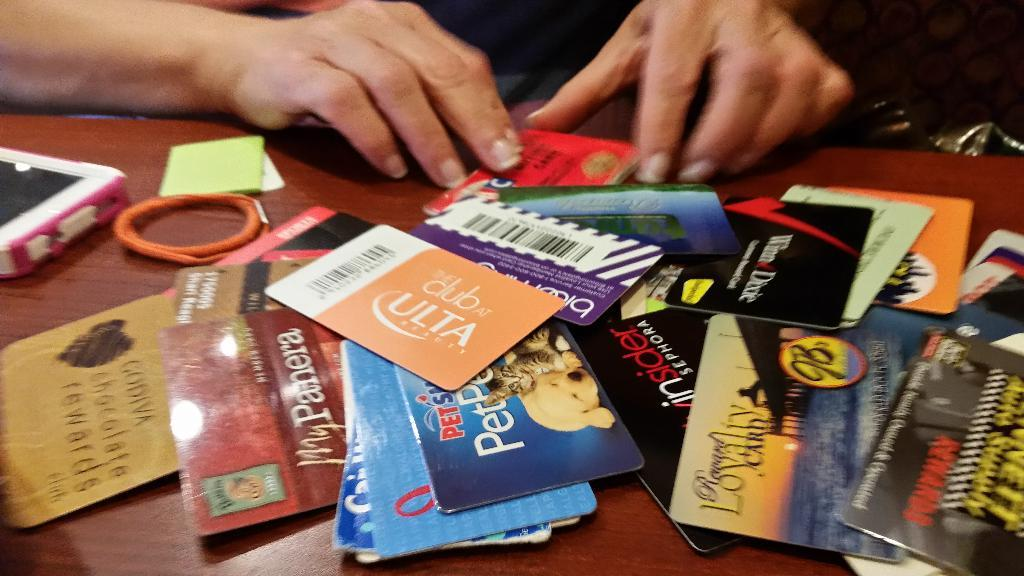<image>
Relay a brief, clear account of the picture shown. A pile of gift cards on a table, one to Club Ulta. 